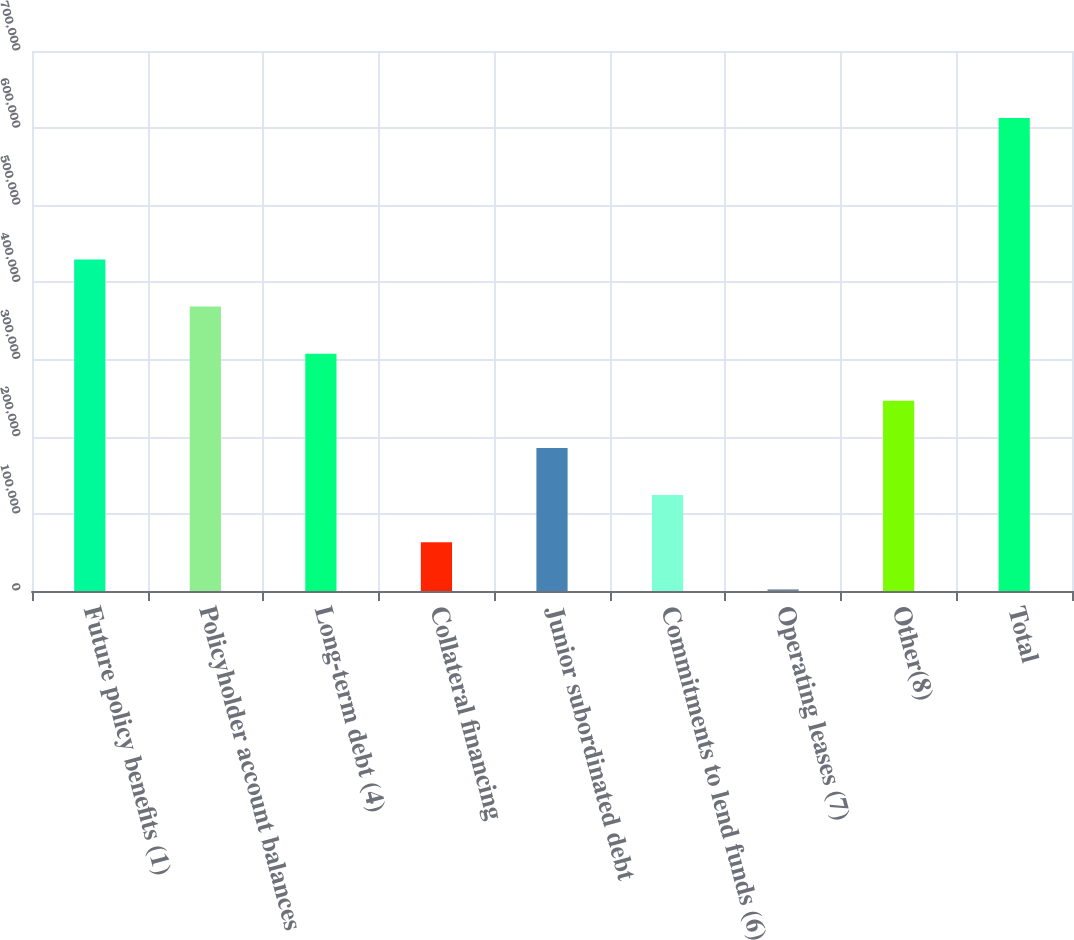Convert chart to OTSL. <chart><loc_0><loc_0><loc_500><loc_500><bar_chart><fcel>Future policy benefits (1)<fcel>Policyholder account balances<fcel>Long-term debt (4)<fcel>Collateral financing<fcel>Junior subordinated debt<fcel>Commitments to lend funds (6)<fcel>Operating leases (7)<fcel>Other(8)<fcel>Total<nl><fcel>429824<fcel>368727<fcel>307629<fcel>63238.6<fcel>185434<fcel>124336<fcel>2141<fcel>246531<fcel>613117<nl></chart> 